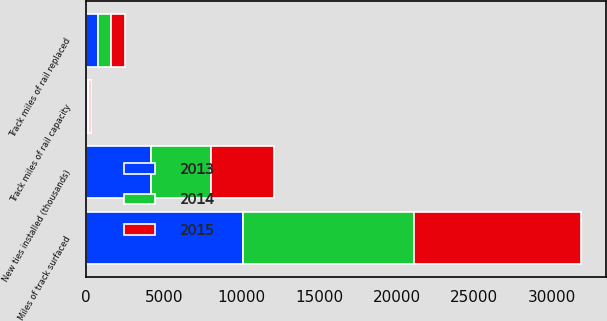Convert chart to OTSL. <chart><loc_0><loc_0><loc_500><loc_500><stacked_bar_chart><ecel><fcel>Track miles of rail replaced<fcel>Track miles of rail capacity<fcel>New ties installed (thousands)<fcel>Miles of track surfaced<nl><fcel>2013<fcel>767<fcel>103<fcel>4178<fcel>10076<nl><fcel>2015<fcel>912<fcel>119<fcel>4076<fcel>10791<nl><fcel>2014<fcel>834<fcel>97<fcel>3870<fcel>11017<nl></chart> 